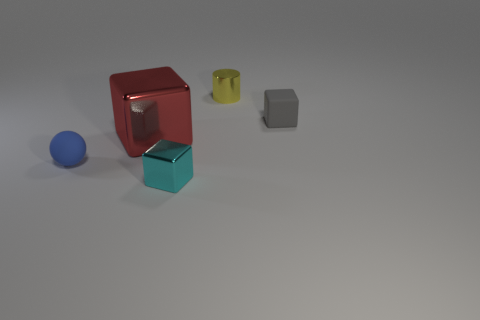Are there fewer small blue things that are right of the tiny yellow cylinder than large red metallic blocks that are in front of the tiny blue matte thing?
Make the answer very short. No. How many brown things are either tiny cubes or large things?
Provide a short and direct response. 0. Are there the same number of tiny cyan blocks on the left side of the blue ball and big red metal cubes?
Your answer should be very brief. No. How many objects are red cubes or small metal blocks in front of the red object?
Keep it short and to the point. 2. Does the shiny cylinder have the same color as the tiny matte sphere?
Offer a terse response. No. Are there any yellow blocks that have the same material as the large thing?
Ensure brevity in your answer.  No. What color is the other big shiny object that is the same shape as the gray thing?
Your answer should be very brief. Red. Do the yellow thing and the object that is in front of the ball have the same material?
Provide a short and direct response. Yes. There is a metal thing that is behind the metal block to the left of the tiny cyan metal block; what is its shape?
Provide a succinct answer. Cylinder. There is a metal cube behind the cyan block; is its size the same as the small cyan shiny object?
Give a very brief answer. No. 